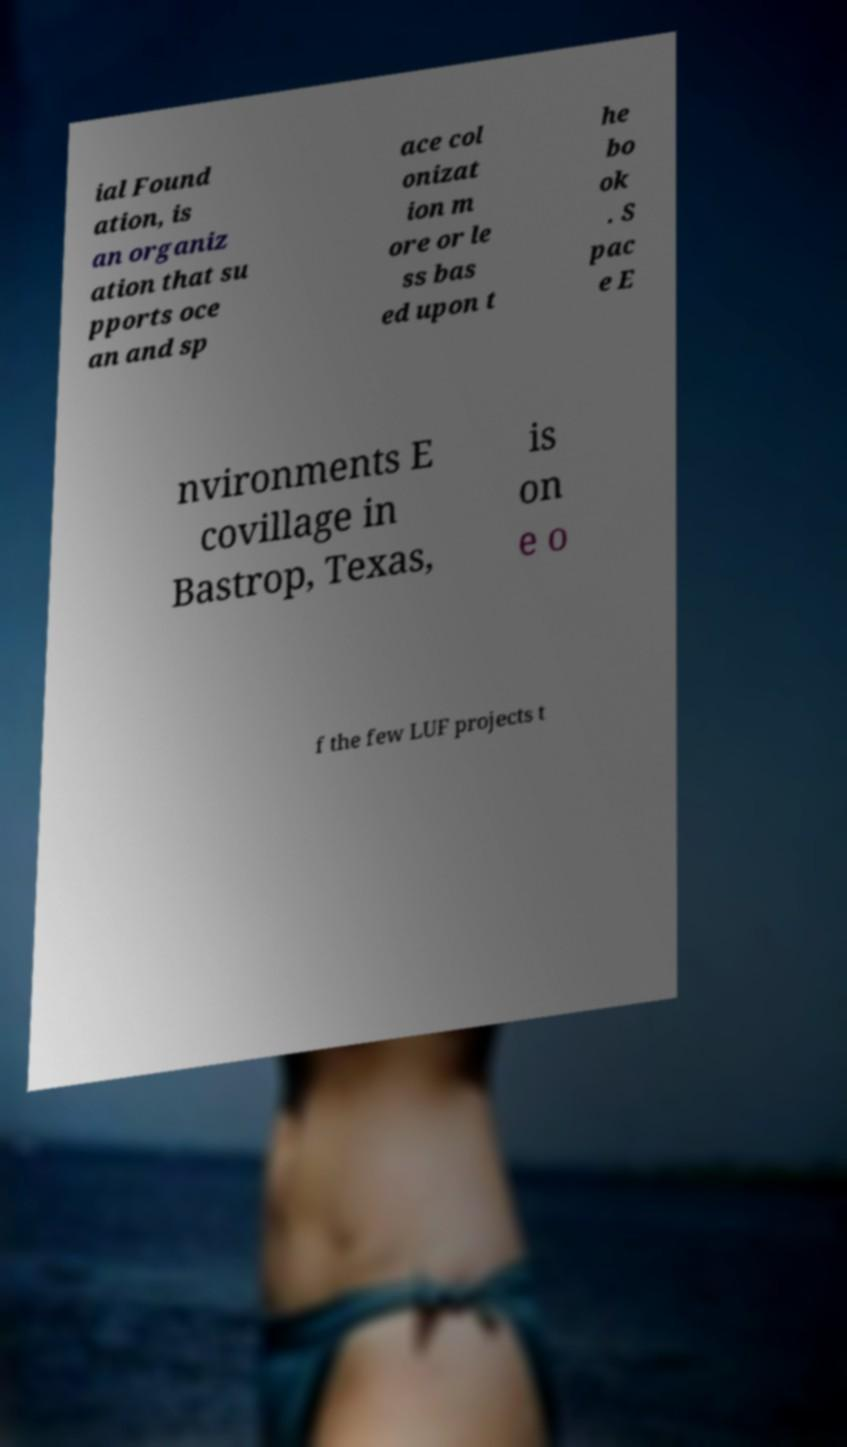Could you extract and type out the text from this image? ial Found ation, is an organiz ation that su pports oce an and sp ace col onizat ion m ore or le ss bas ed upon t he bo ok . S pac e E nvironments E covillage in Bastrop, Texas, is on e o f the few LUF projects t 